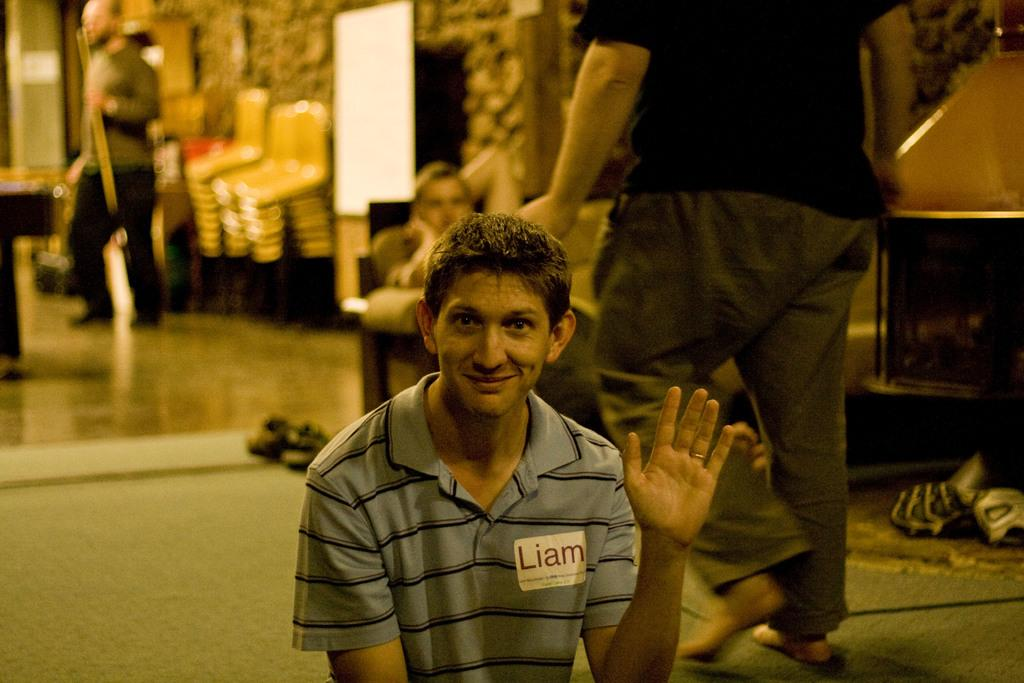How many people are in the image? There are people in the image, but the exact number cannot be determined from the provided facts. What type of furniture is present in the image? There are chairs and a table in the image. What is the purpose of the board in the image? The purpose of the board in the image cannot be determined from the provided facts. What objects can be seen on the floor in the image? There are objects on the floor in the image, but their specific nature cannot be determined from the provided facts. What is visible on the wall in the image? The specific details of the wall in the image cannot be determined from the provided facts. How many beans are on the feet of the people in the image? There are no beans or feet mentioned in the provided facts, so this question cannot be answered. 